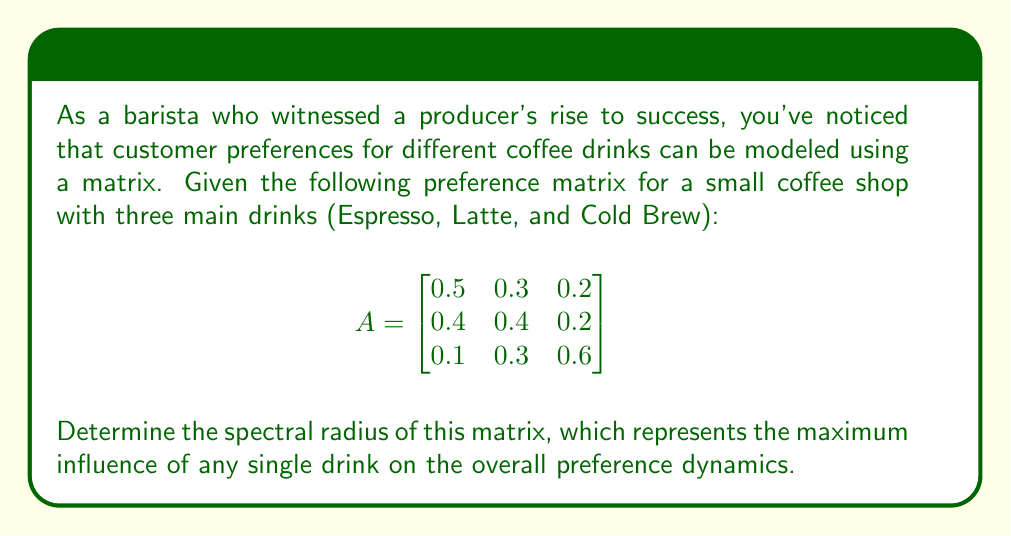Help me with this question. To find the spectral radius of matrix A, we need to follow these steps:

1) First, calculate the eigenvalues of the matrix A.

2) The characteristic equation is given by $\det(A - \lambda I) = 0$, where I is the 3x3 identity matrix.

3) Expanding this:

   $$\begin{vmatrix}
   0.5-\lambda & 0.3 & 0.2 \\
   0.4 & 0.4-\lambda & 0.2 \\
   0.1 & 0.3 & 0.6-\lambda
   \end{vmatrix} = 0$$

4) This expands to:
   
   $(0.5-\lambda)((0.4-\lambda)(0.6-\lambda)-0.06) - 0.3(0.4(0.6-\lambda)-0.02) + 0.2(0.12-0.3(0.4-\lambda)) = 0$

5) Simplifying:

   $-\lambda^3 + 1.5\lambda^2 - 0.66\lambda + 0.084 = 0$

6) Solving this cubic equation (using a computer algebra system or numerical methods) gives us the eigenvalues:

   $\lambda_1 \approx 1.0085$
   $\lambda_2 \approx 0.2723$
   $\lambda_3 \approx 0.2192$

7) The spectral radius is the maximum absolute value of these eigenvalues.

Therefore, the spectral radius is approximately 1.0085.
Answer: The spectral radius of the given preference matrix is approximately 1.0085. 